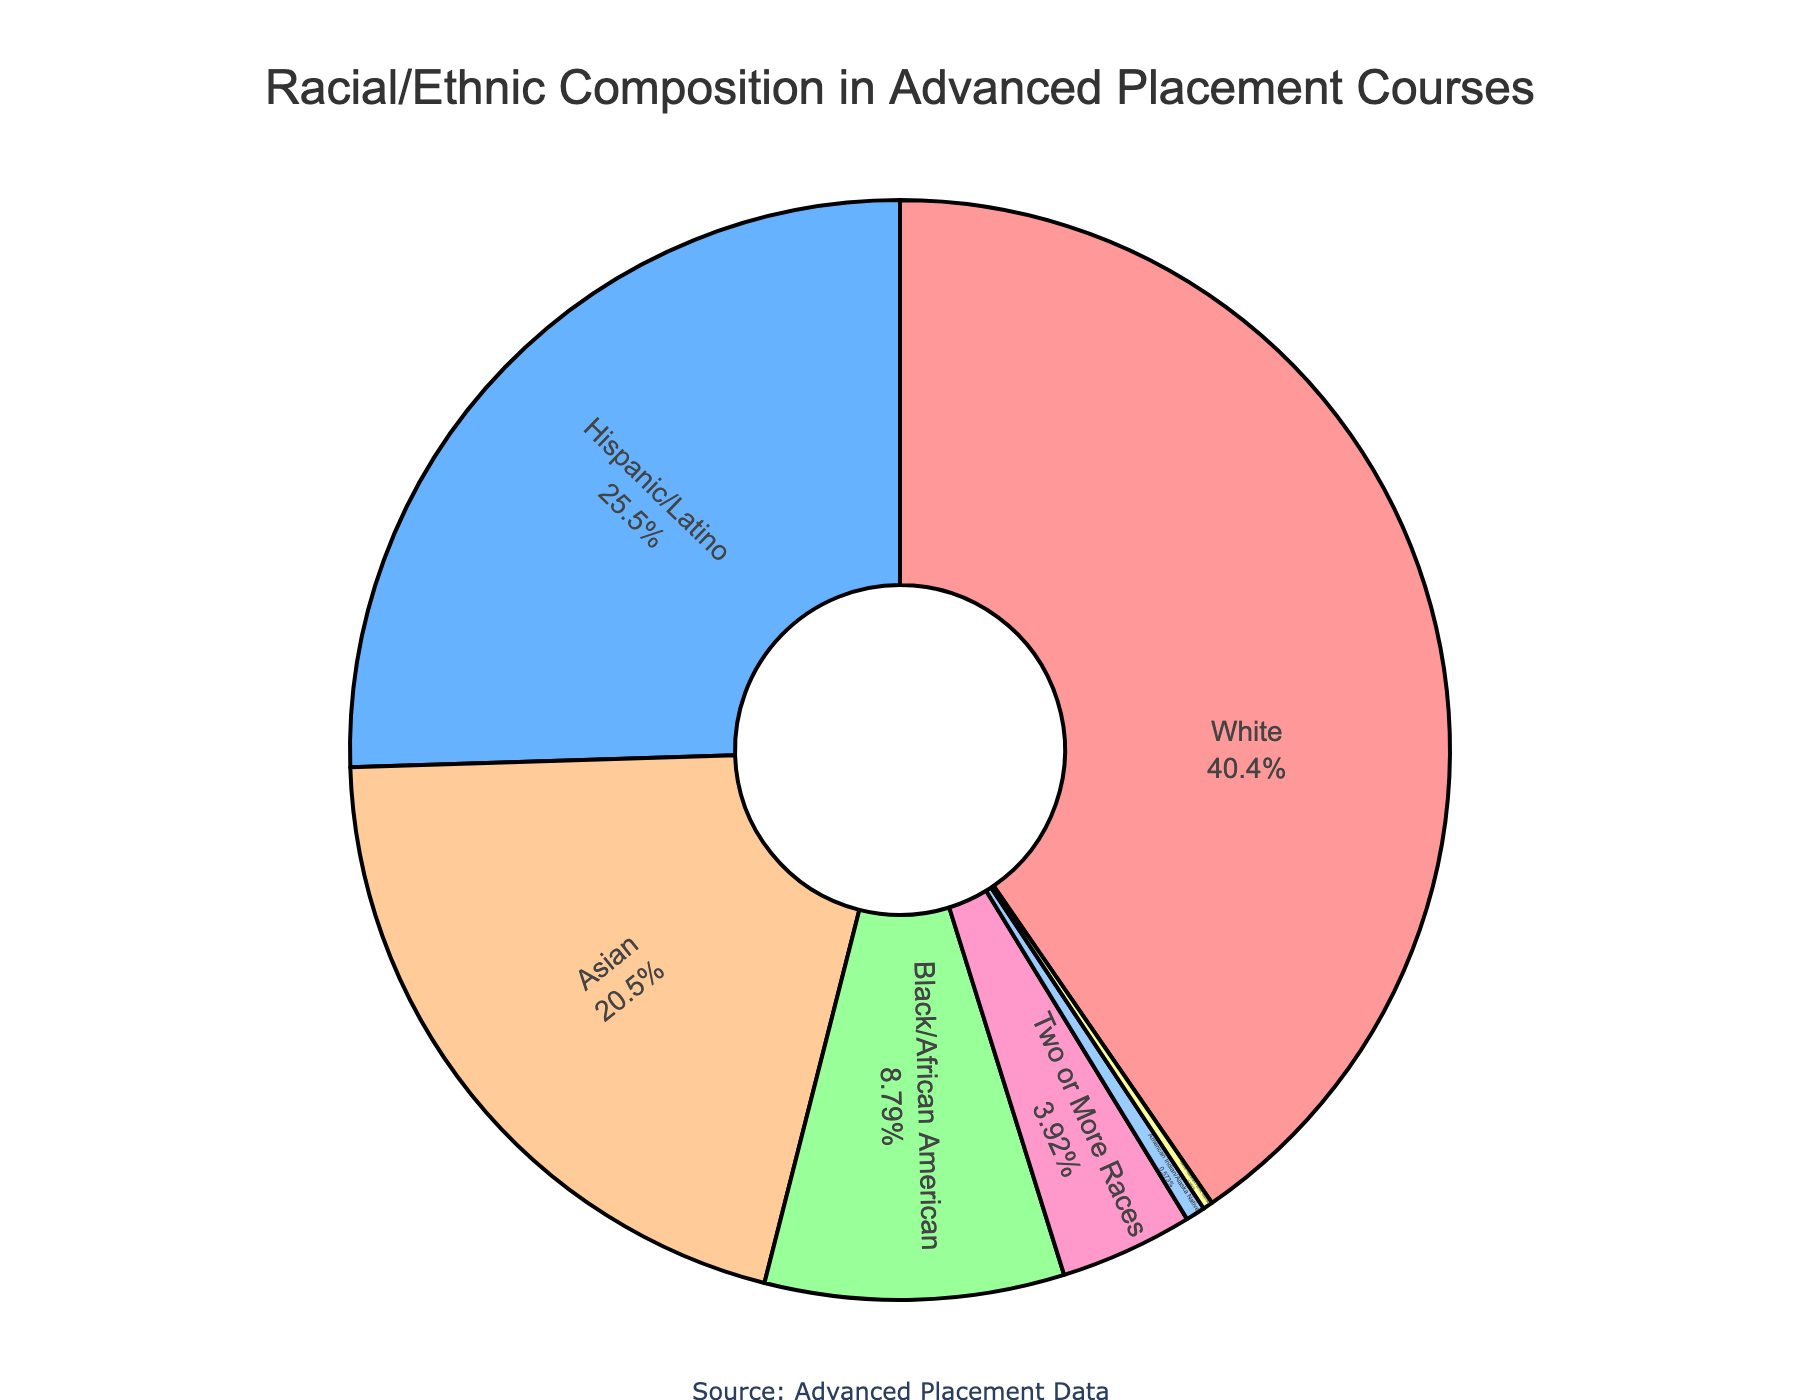What's the largest racial/ethnic group present in advanced placement courses? Look for the racial/ethnic group with the highest percentage in the pie chart. White students have the largest portion at 42.3%.
Answer: White Which racial/ethnic group has the smallest percentage? Locate the smallest segment in the pie chart and look at the corresponding label. Native Hawaiian/Pacific Islander has the smallest slice at 0.3%.
Answer: Native Hawaiian/Pacific Islander How much smaller is the percentage of Black/African American students compared to White students? Subtract the percentage of Black/African American students (9.2%) from the percentage of White students (42.3%). The difference is 42.3% - 9.2% = 33.1%.
Answer: 33.1% What is the combined percentage of Hispanic/Latino and Asian students? Add the percentages of Hispanic/Latino (26.7%) and Asian students (21.5%). The sum is 26.7% + 21.5% = 48.2%.
Answer: 48.2% Which two racial/ethnic groups combined have the lowest representation? Identify the two smallest segments on the pie chart: Native Hawaiian/Pacific Islander (0.3%) and American Indian/Alaska Native (0.6%). Add these together: 0.3% + 0.6% = 0.9%.
Answer: Native Hawaiian/Pacific Islander and American Indian/Alaska Native What percentage of students do not belong to the four largest racial/ethnic groups (White, Hispanic/Latino, Black/African American, Asian)? First, find the sum of the four largest groups: 42.3% (White) + 26.7% (Hispanic/Latino) + 9.2% (Black/African American) + 21.5% (Asian) = 99.7%. Subtract this from 100% to find the remaining percentage: 100% - 99.7% = 0.3%.
Answer: 0.3% How many racial/ethnic groups have a percentage of students greater than 20%? Identify segments with percentages greater than 20%. The relevant groups are White (42.3%) and Hispanic/Latino (26.7%). There are two groups in total.
Answer: 2 What is the difference in percentage between Hispanic/Latino and Asian students? Subtract the percentage of Asian students (21.5%) from the percentage of Hispanic/Latino students (26.7%). The difference is 26.7% - 21.5% = 5.2%.
Answer: 5.2% What is the color used for Two or More Races in the pie chart? Identify the segment labeled Two or More Races and note its color. It is pink.
Answer: pink 